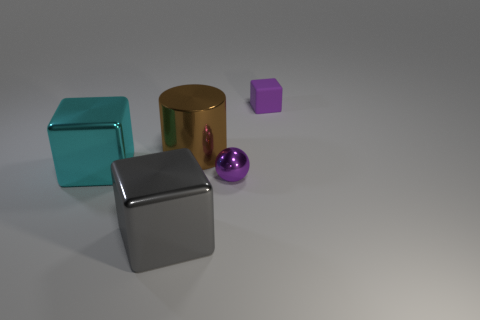Can you describe the lighting and shadows in the scene? The image features a soft and diffuse lighting, likely from a source above and to the right, given the shadows cast by the objects. These shadows are soft-edged and elongated, suggesting the light source is not extremely close to the objects. The lighting angle emphasizes the textures of the objects and gives the scene a calm and balanced composition. 